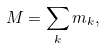<formula> <loc_0><loc_0><loc_500><loc_500>M = \sum _ { k } { m _ { k } } ,</formula> 